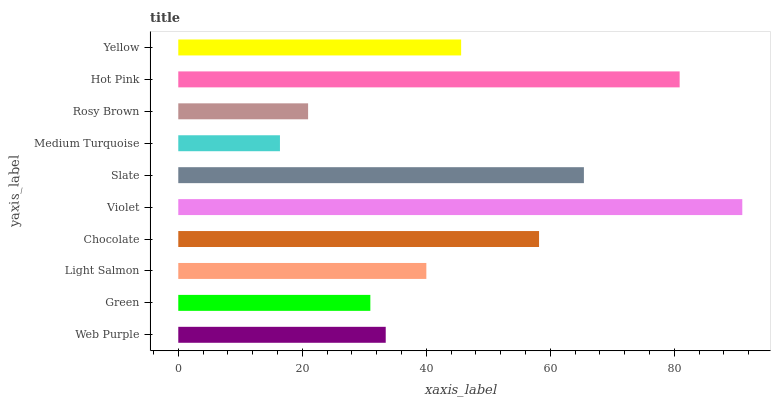Is Medium Turquoise the minimum?
Answer yes or no. Yes. Is Violet the maximum?
Answer yes or no. Yes. Is Green the minimum?
Answer yes or no. No. Is Green the maximum?
Answer yes or no. No. Is Web Purple greater than Green?
Answer yes or no. Yes. Is Green less than Web Purple?
Answer yes or no. Yes. Is Green greater than Web Purple?
Answer yes or no. No. Is Web Purple less than Green?
Answer yes or no. No. Is Yellow the high median?
Answer yes or no. Yes. Is Light Salmon the low median?
Answer yes or no. Yes. Is Chocolate the high median?
Answer yes or no. No. Is Green the low median?
Answer yes or no. No. 